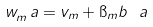Convert formula to latex. <formula><loc_0><loc_0><loc_500><loc_500>w _ { m } ^ { \ } a = v _ { m } + \i _ { m } b ^ { \ } a</formula> 